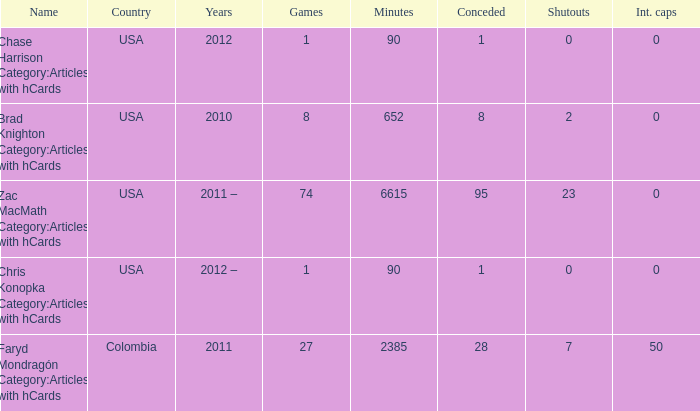When  chris konopka category:articles with hcards is the name what is the year? 2012 –. I'm looking to parse the entire table for insights. Could you assist me with that? {'header': ['Name', 'Country', 'Years', 'Games', 'Minutes', 'Conceded', 'Shutouts', 'Int. caps'], 'rows': [['Chase Harrison Category:Articles with hCards', 'USA', '2012', '1', '90', '1', '0', '0'], ['Brad Knighton Category:Articles with hCards', 'USA', '2010', '8', '652', '8', '2', '0'], ['Zac MacMath Category:Articles with hCards', 'USA', '2011 –', '74', '6615', '95', '23', '0'], ['Chris Konopka Category:Articles with hCards', 'USA', '2012 –', '1', '90', '1', '0', '0'], ['Faryd Mondragón Category:Articles with hCards', 'Colombia', '2011', '27', '2385', '28', '7', '50']]} 